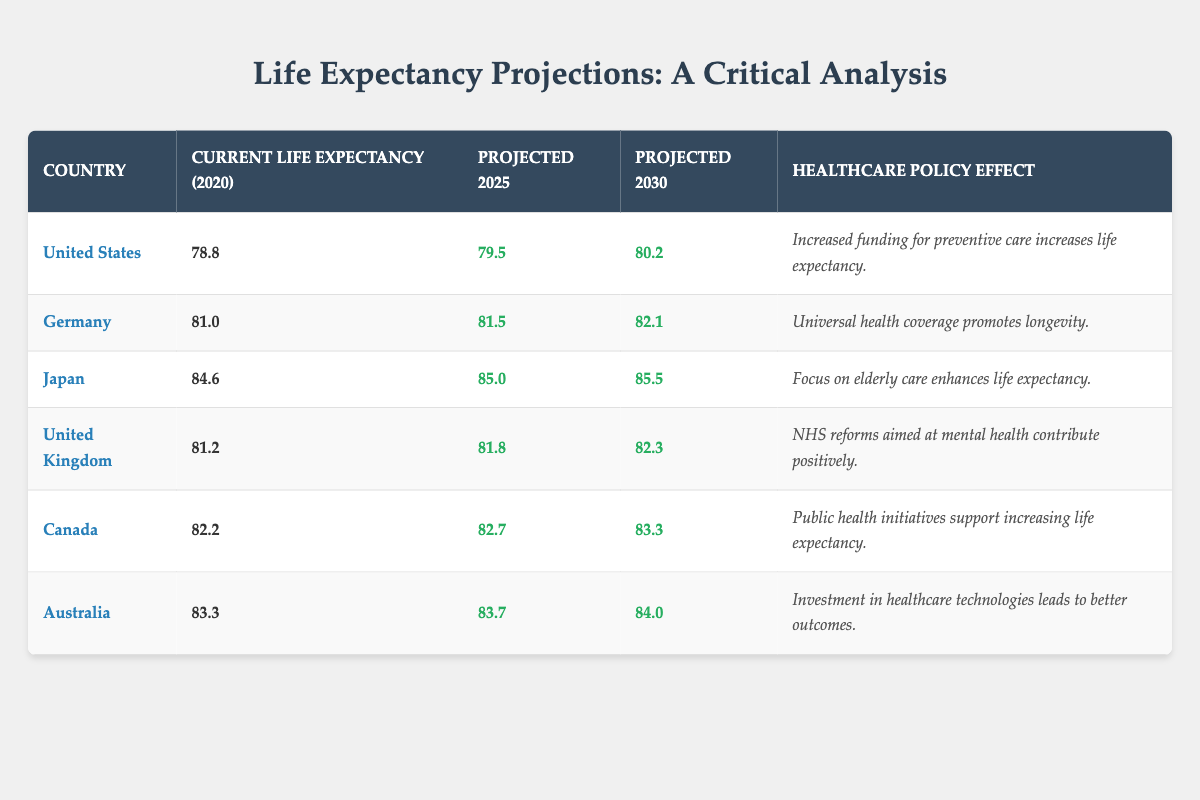What is the current life expectancy in Germany? In the table, Germany's current life expectancy given for the base year 2020 is listed in the second column. It shows a value of 81.0 years.
Answer: 81.0 What is the projected life expectancy for Japan in 2030? According to the table, the projected life expectancy for Japan in the year 2030 is found in the fourth column. The value listed is 85.5 years.
Answer: 85.5 Which country has the highest current life expectancy? By examining the table, we see the current life expectancy values: United States (78.8), Germany (81.0), Japan (84.6), United Kingdom (81.2), Canada (82.2), and Australia (83.3). Japan has the highest value at 84.6 years.
Answer: Japan Is the projected life expectancy for Australia higher than that for Canada in 2025? Looking at the projected life expectancy for 2025, Australia is listed at 83.7 and Canada at 82.7. Since 83.7 is greater than 82.7, the statement is true.
Answer: Yes What is the average projected life expectancy across all countries for 2030? To find the average, sum the projected life expectancy for 2030 of all countries: (80.2 + 82.1 + 85.5 + 82.3 + 83.3 + 84.0) = 497.4. Then, divide by the number of countries (6): 497.4 / 6 = 82.9. Thus, the average is 82.9 years.
Answer: 82.9 What is the difference in current life expectancy between the United States and Canada? The current life expectancy for the United States is 78.8 and for Canada is 82.2. To find the difference, subtract the United States life expectancy from Canada's: 82.2 - 78.8 = 3.4. Therefore, the difference is 3.4 years.
Answer: 3.4 Does the United Kingdom's healthcare policy effect mention improvements in mental health? In the table, the healthcare policy effect for the United Kingdom explicitly states that NHS reforms aimed at mental health contribute positively. This confirms that the statement is true.
Answer: Yes Which country shows the smallest increase in projected life expectancy from 2025 to 2030? To find this, look at the projected increases: United States (0.7), Germany (0.6), Japan (0.5), United Kingdom (0.5), Canada (0.6), and Australia (0.3). The smallest increase is for Australia, which shows an increase of 0.3 years.
Answer: Australia 